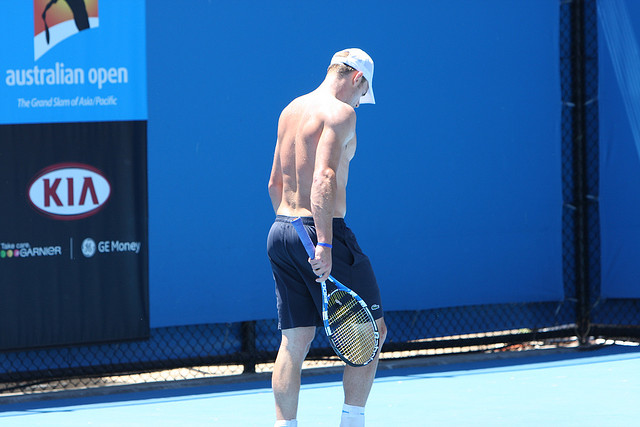What might the tennis player's routine look like leading up to a big match? In the days leading up to a big match like the Australian Open, the tennis player follows a meticulously planned routine. He starts his day early with a balanced breakfast rich in proteins and carbohydrates to fuel his training. The morning sessions are dedicated to intense practice, focusing on various aspects of his game such as serves, volleys, and footwork. These sessions are often accompanied by his coach’s guidance, ensuring that every movement is refined and precise.

After the morning practice, he takes a break to hydrate and consume a light snack. Midday includes a combination of physical conditioning and tactical discussions with his team, reviewing past matches and strategizing for the upcoming game. The afternoon is often spent on drills that simulate match conditions, reinforcing his mental toughness and game strategy.

Evenings are reserved for recovery, incorporating activities like stretching, yoga, and massages to alleviate muscle tension. He also undergoes an ice bath session to facilitate faster recovery. His diet throughout the day is monitored, ensuring he maintains optimum energy levels and muscle recovery.

In the final hours before the match, he indulges in some light practice to keep his reflexes sharp, followed by a relaxing routine to calm his nerves, which might include listening to music or a brief meditation session. This systematic approach not only keeps him physically prepared but also mentally resilient, ready to face the challenges of the big match ahead. 